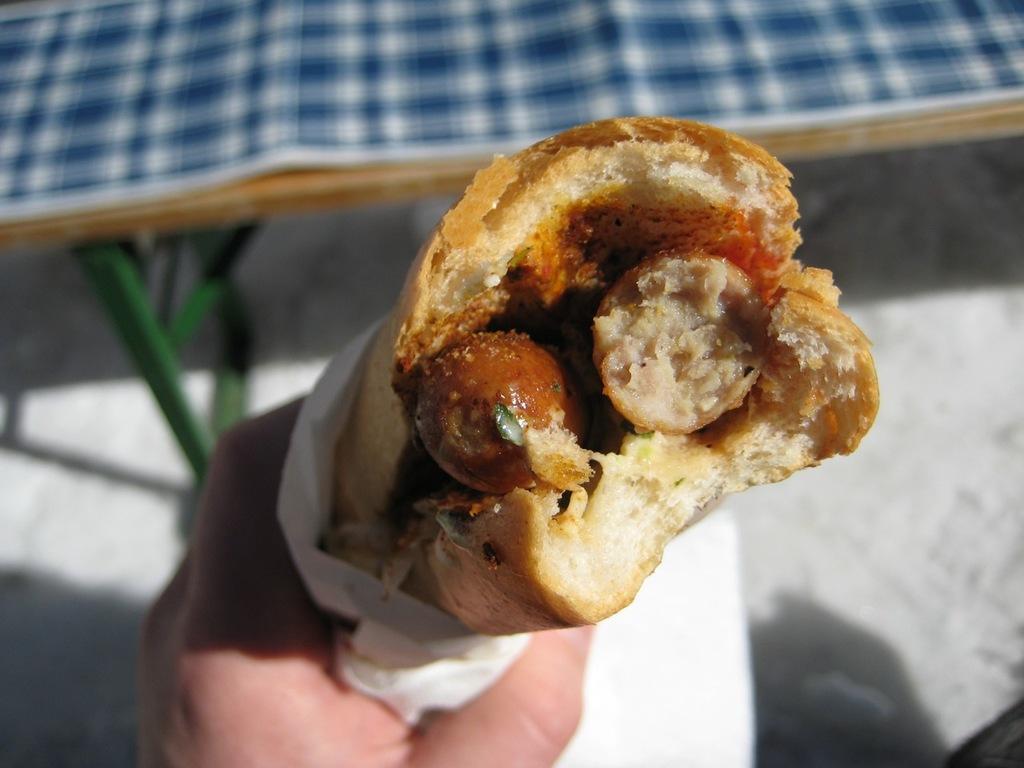Could you give a brief overview of what you see in this image? In this picture, we see the hand of the person who is holding the food item and tissue paper. At the bottom of the picture, it is white in color. In the background, we see a table which is covered with blue and white color sheet. This picture is blurred in the background. 